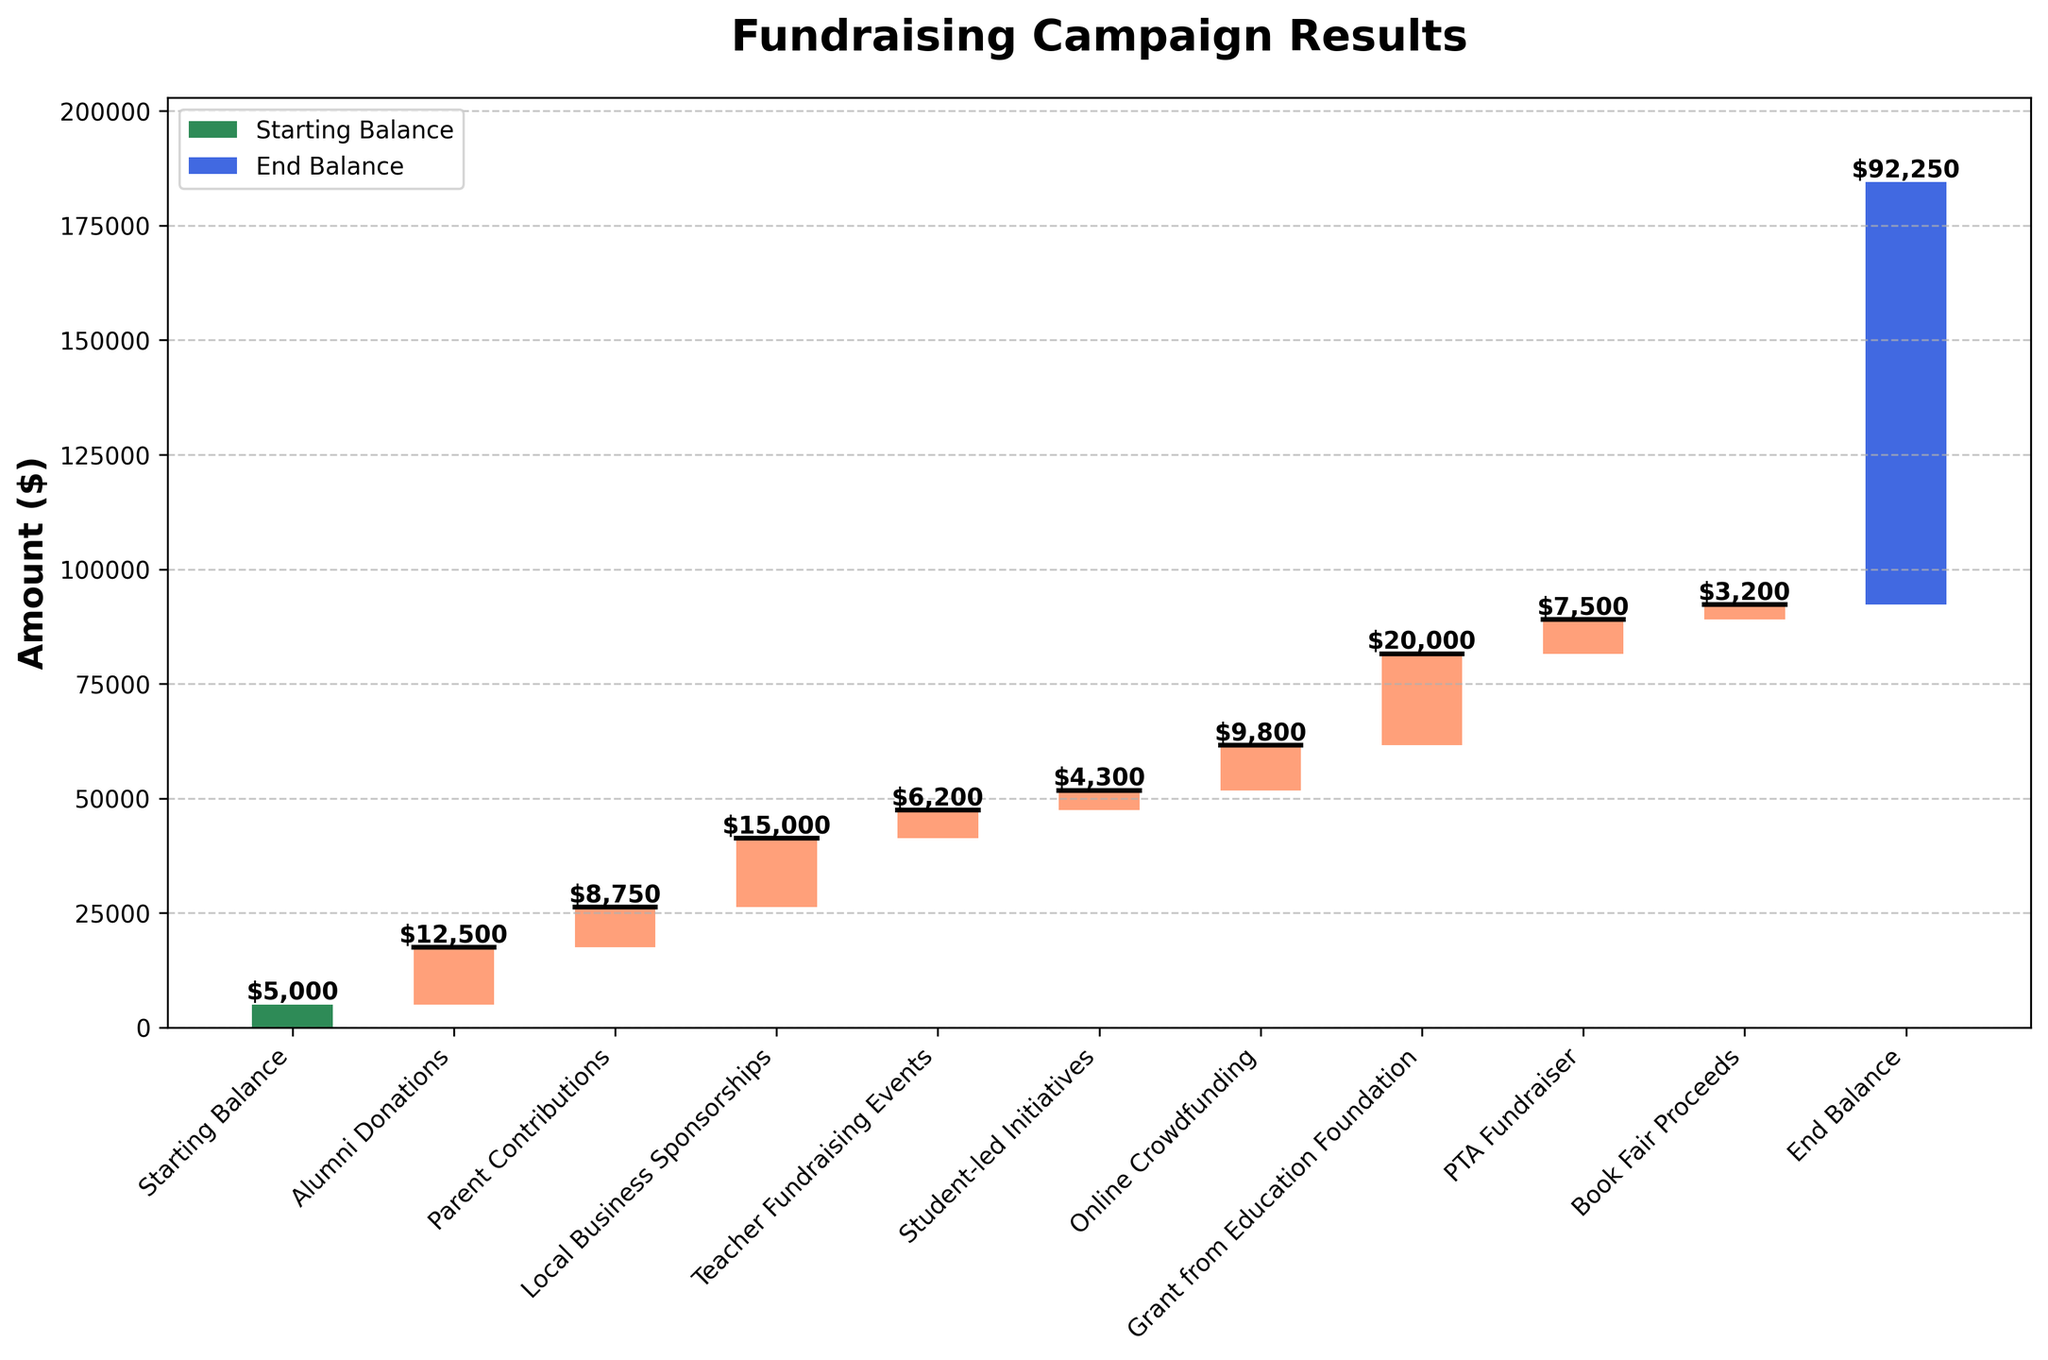What is the title of the chart? The title of the chart is displayed at the top of the figure, providing a summary or main point of the visual. Here, the title is "Fundraising Campaign Results."
Answer: Fundraising Campaign Results How many categories are shown in the chart? To determine the number of categories, count the individual bars or data points labeled on the x-axis. Here, they represent different contribution sources.
Answer: 10 What is the final amount shown in the chart? The final amount, or end balance, is indicated by the last bar on the right side, which has a label with the numerical value.
Answer: $92,250 Which category contributed the highest value? Scan through the bars to identify which bar reaches the highest point, then refer to its label. The "Grant from Education Foundation" bar is the highest.
Answer: Grant from Education Foundation How much did teacher fundraising events contribute? Look for the bar labeled "Teacher Fundraising Events" and read the numerical value associated with it.
Answer: $6,200 What is the sum of contributions from Alumni Donations and Parent Contributions? Add the values of the bars labeled "Alumni Donations" and "Parent Contributions." Alumni Donations = $12,500 and Parent Contributions = $8,750. So, $12,500 + $8,750.
Answer: $21,250 How does the contribution from local business sponsorships compare to the total contribution from student-led initiatives and online crowdfunding? Compare the height/values of "Local Business Sponsorships" against the sum of "Student-led Initiatives" and "Online Crowdfunding." "Local Business Sponsorships" is $15,000, while "Student-led Initiatives" is $4,300 and "Online Crowdfunding" is $9,800. The sum is $4,300 + $9,800 = $14,100. Compare $15,000 vs. $14,100.
Answer: Local Business Sponsorships contributed more What is the average contribution excluding the starting and ending balances? Exclude the "Starting Balance" and "End Balance," then calculate the average of the remaining values. [(12500 + 8750 + 15000 + 6200 + 4300 + 9800 + 20000 + 7500 + 3200) / 9].
Answer: $10,027.78 If we combine the contributions from the PTA Fundraiser, Book Fair Proceeds, and Teacher Fundraising Events, what is the total? Add the values of "PTA Fundraiser," "Book Fair Proceeds," and "Teacher Fundraising Events." PTA Fundraiser = $7,500, Book Fair Proceeds = $3,200, Teacher Fundraising Events = $6,200. So, $7,500 + $3,200 + $6,200.
Answer: $16,900 What is the difference between the highest and the lowest contribution categories? Identify the highest and lowest values from the bars. The highest is "Grant from Education Foundation" = $20,000, and the lowest is "Book Fair Proceeds" = $3,200. Subtract to find the difference: $20,000 - $3,200.
Answer: $16,800 